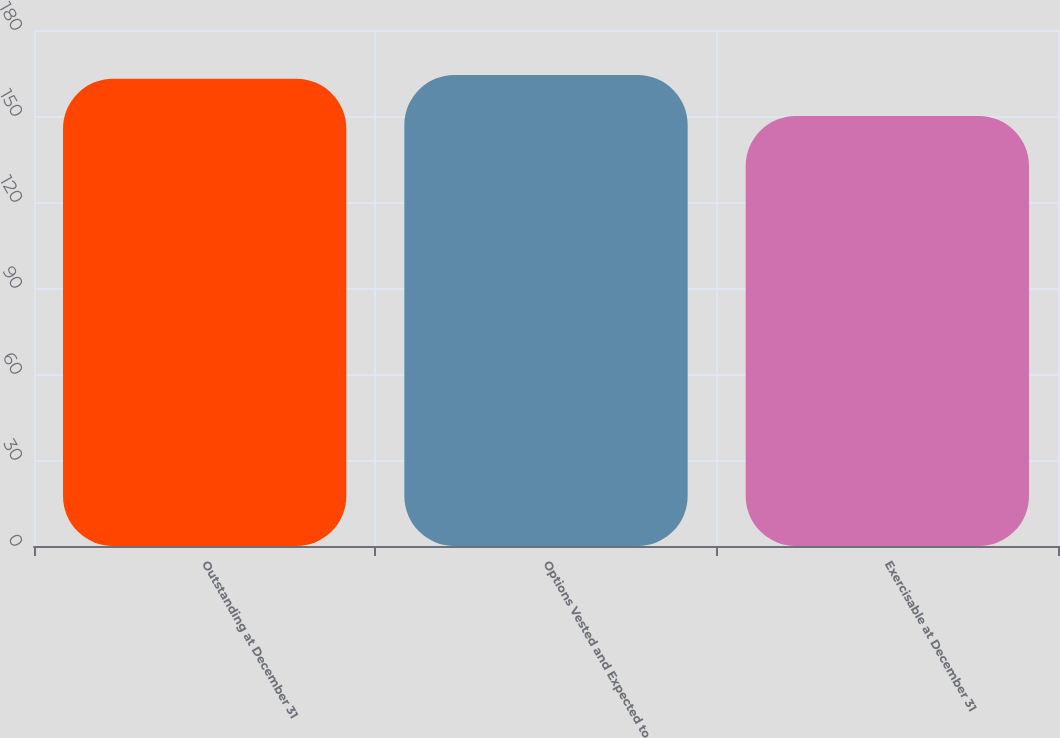<chart> <loc_0><loc_0><loc_500><loc_500><bar_chart><fcel>Outstanding at December 31<fcel>Options Vested and Expected to<fcel>Exercisable at December 31<nl><fcel>163<fcel>164.3<fcel>150<nl></chart> 